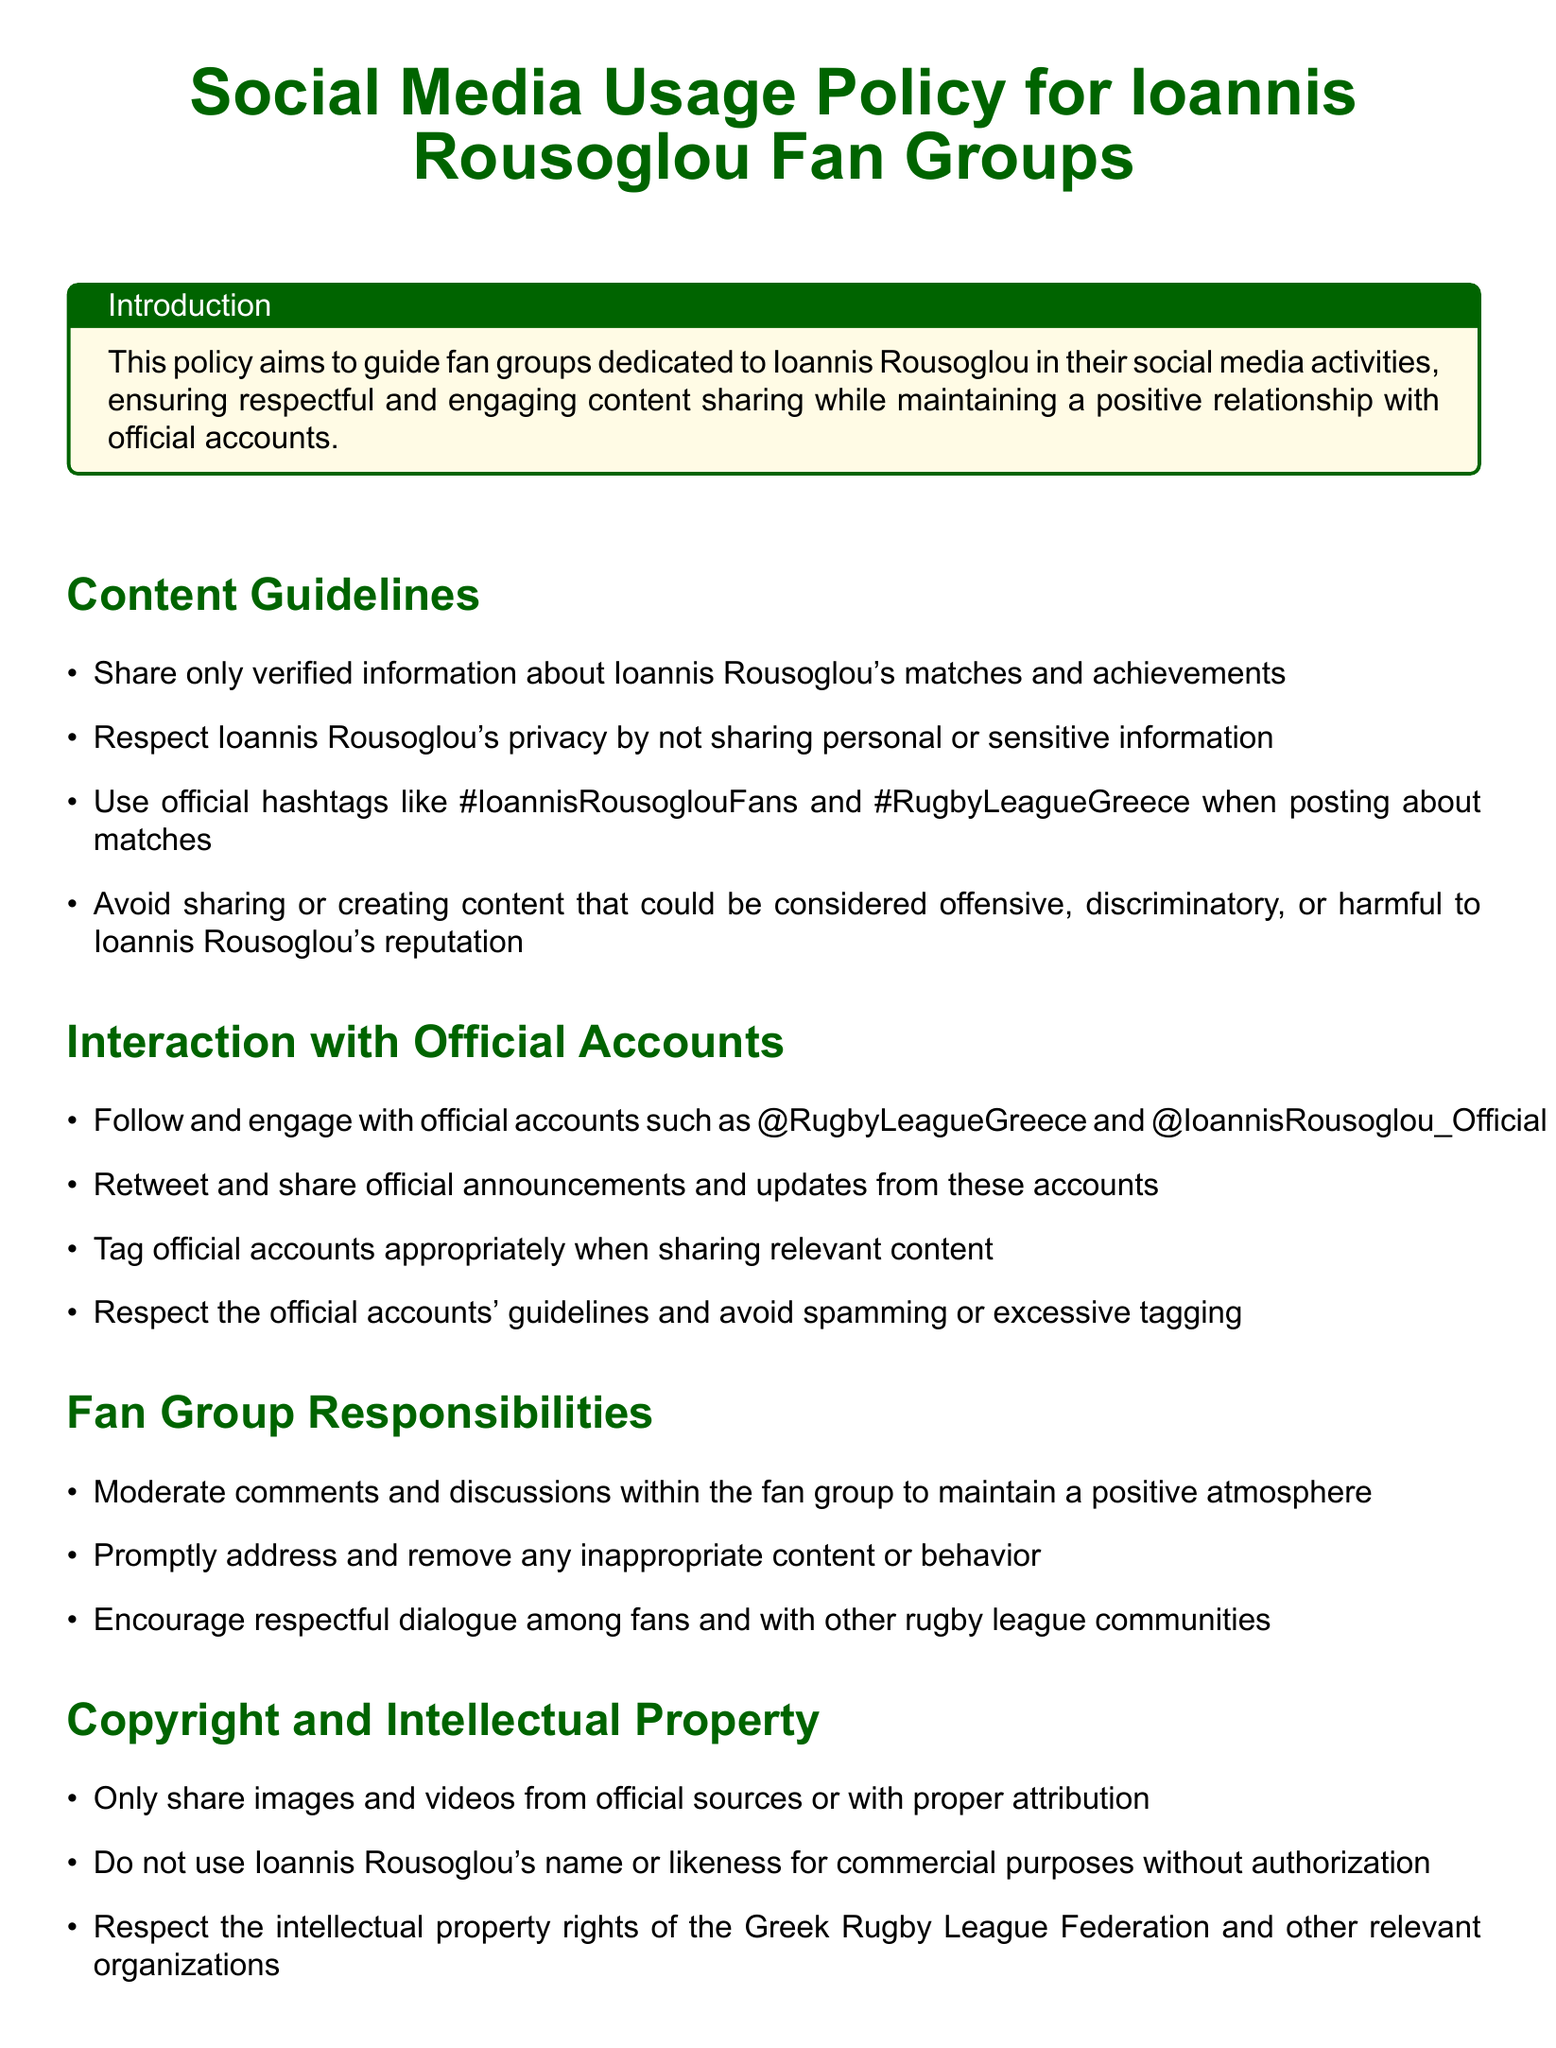What is the title of the document? The title is prominently displayed at the top of the document, stating its purpose for fan groups.
Answer: Social Media Usage Policy for Ioannis Rousoglou Fan Groups What are the official hashtags mentioned? The document lists specific hashtags that fans are encouraged to use when posting about matches.
Answer: #IoannisRousoglouFans and #RugbyLeagueGreece What should fan groups avoid sharing? The guidelines specifically mention types of content that should not be shared to maintain a positive environment.
Answer: Offensive, discriminatory, or harmful content Who should fan groups follow on social media? The document outlines the official social media accounts fans should engage with for updates.
Answer: @RugbyLeagueGreece and @IoannisRousoglou_Official What is the consequence of not following the guidelines? The document specifies repercussions for members who fail to adhere to the policy.
Answer: Removal from the fan group or restrictions on social media participation Why is image sharing from official sources important? The document emphasizes the significance of respecting copyright and intellectual property related to shared content.
Answer: Copyright and intellectual property rights What should fan groups encourage among members? The responsibilities section outlines important interactions that should be promoted within the fan community.
Answer: Respectful dialogue among fans What is the purpose of this policy? The introduction provides the main goal of the policy concerning fan group activity.
Answer: To guide fan groups in their social media activities 